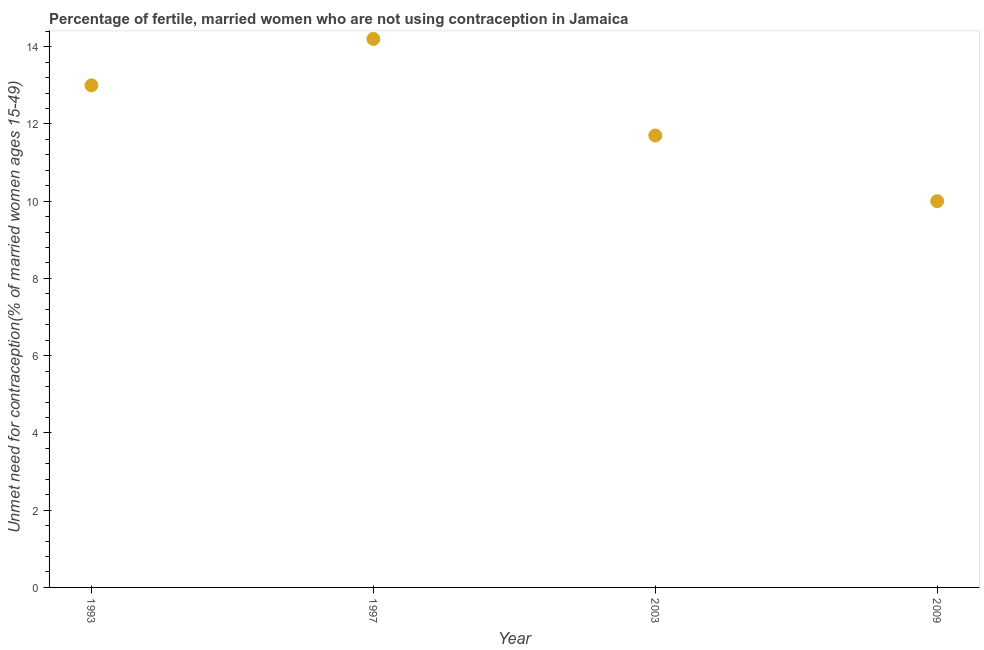Across all years, what is the minimum number of married women who are not using contraception?
Ensure brevity in your answer.  10. In which year was the number of married women who are not using contraception maximum?
Make the answer very short. 1997. What is the sum of the number of married women who are not using contraception?
Offer a terse response. 48.9. What is the difference between the number of married women who are not using contraception in 1997 and 2009?
Give a very brief answer. 4.2. What is the average number of married women who are not using contraception per year?
Offer a very short reply. 12.22. What is the median number of married women who are not using contraception?
Offer a very short reply. 12.35. In how many years, is the number of married women who are not using contraception greater than 13.6 %?
Offer a terse response. 1. Do a majority of the years between 1997 and 2003 (inclusive) have number of married women who are not using contraception greater than 12.4 %?
Ensure brevity in your answer.  No. What is the ratio of the number of married women who are not using contraception in 1997 to that in 2009?
Provide a short and direct response. 1.42. What is the difference between the highest and the second highest number of married women who are not using contraception?
Your response must be concise. 1.2. What is the difference between the highest and the lowest number of married women who are not using contraception?
Provide a succinct answer. 4.2. In how many years, is the number of married women who are not using contraception greater than the average number of married women who are not using contraception taken over all years?
Provide a short and direct response. 2. What is the difference between two consecutive major ticks on the Y-axis?
Your response must be concise. 2. Does the graph contain any zero values?
Ensure brevity in your answer.  No. Does the graph contain grids?
Keep it short and to the point. No. What is the title of the graph?
Give a very brief answer. Percentage of fertile, married women who are not using contraception in Jamaica. What is the label or title of the Y-axis?
Offer a terse response.  Unmet need for contraception(% of married women ages 15-49). What is the  Unmet need for contraception(% of married women ages 15-49) in 2003?
Ensure brevity in your answer.  11.7. What is the  Unmet need for contraception(% of married women ages 15-49) in 2009?
Provide a succinct answer. 10. What is the difference between the  Unmet need for contraception(% of married women ages 15-49) in 1993 and 2003?
Provide a short and direct response. 1.3. What is the difference between the  Unmet need for contraception(% of married women ages 15-49) in 1993 and 2009?
Make the answer very short. 3. What is the difference between the  Unmet need for contraception(% of married women ages 15-49) in 1997 and 2003?
Make the answer very short. 2.5. What is the difference between the  Unmet need for contraception(% of married women ages 15-49) in 1997 and 2009?
Make the answer very short. 4.2. What is the difference between the  Unmet need for contraception(% of married women ages 15-49) in 2003 and 2009?
Make the answer very short. 1.7. What is the ratio of the  Unmet need for contraception(% of married women ages 15-49) in 1993 to that in 1997?
Ensure brevity in your answer.  0.92. What is the ratio of the  Unmet need for contraception(% of married women ages 15-49) in 1993 to that in 2003?
Ensure brevity in your answer.  1.11. What is the ratio of the  Unmet need for contraception(% of married women ages 15-49) in 1997 to that in 2003?
Your answer should be compact. 1.21. What is the ratio of the  Unmet need for contraception(% of married women ages 15-49) in 1997 to that in 2009?
Ensure brevity in your answer.  1.42. What is the ratio of the  Unmet need for contraception(% of married women ages 15-49) in 2003 to that in 2009?
Provide a succinct answer. 1.17. 